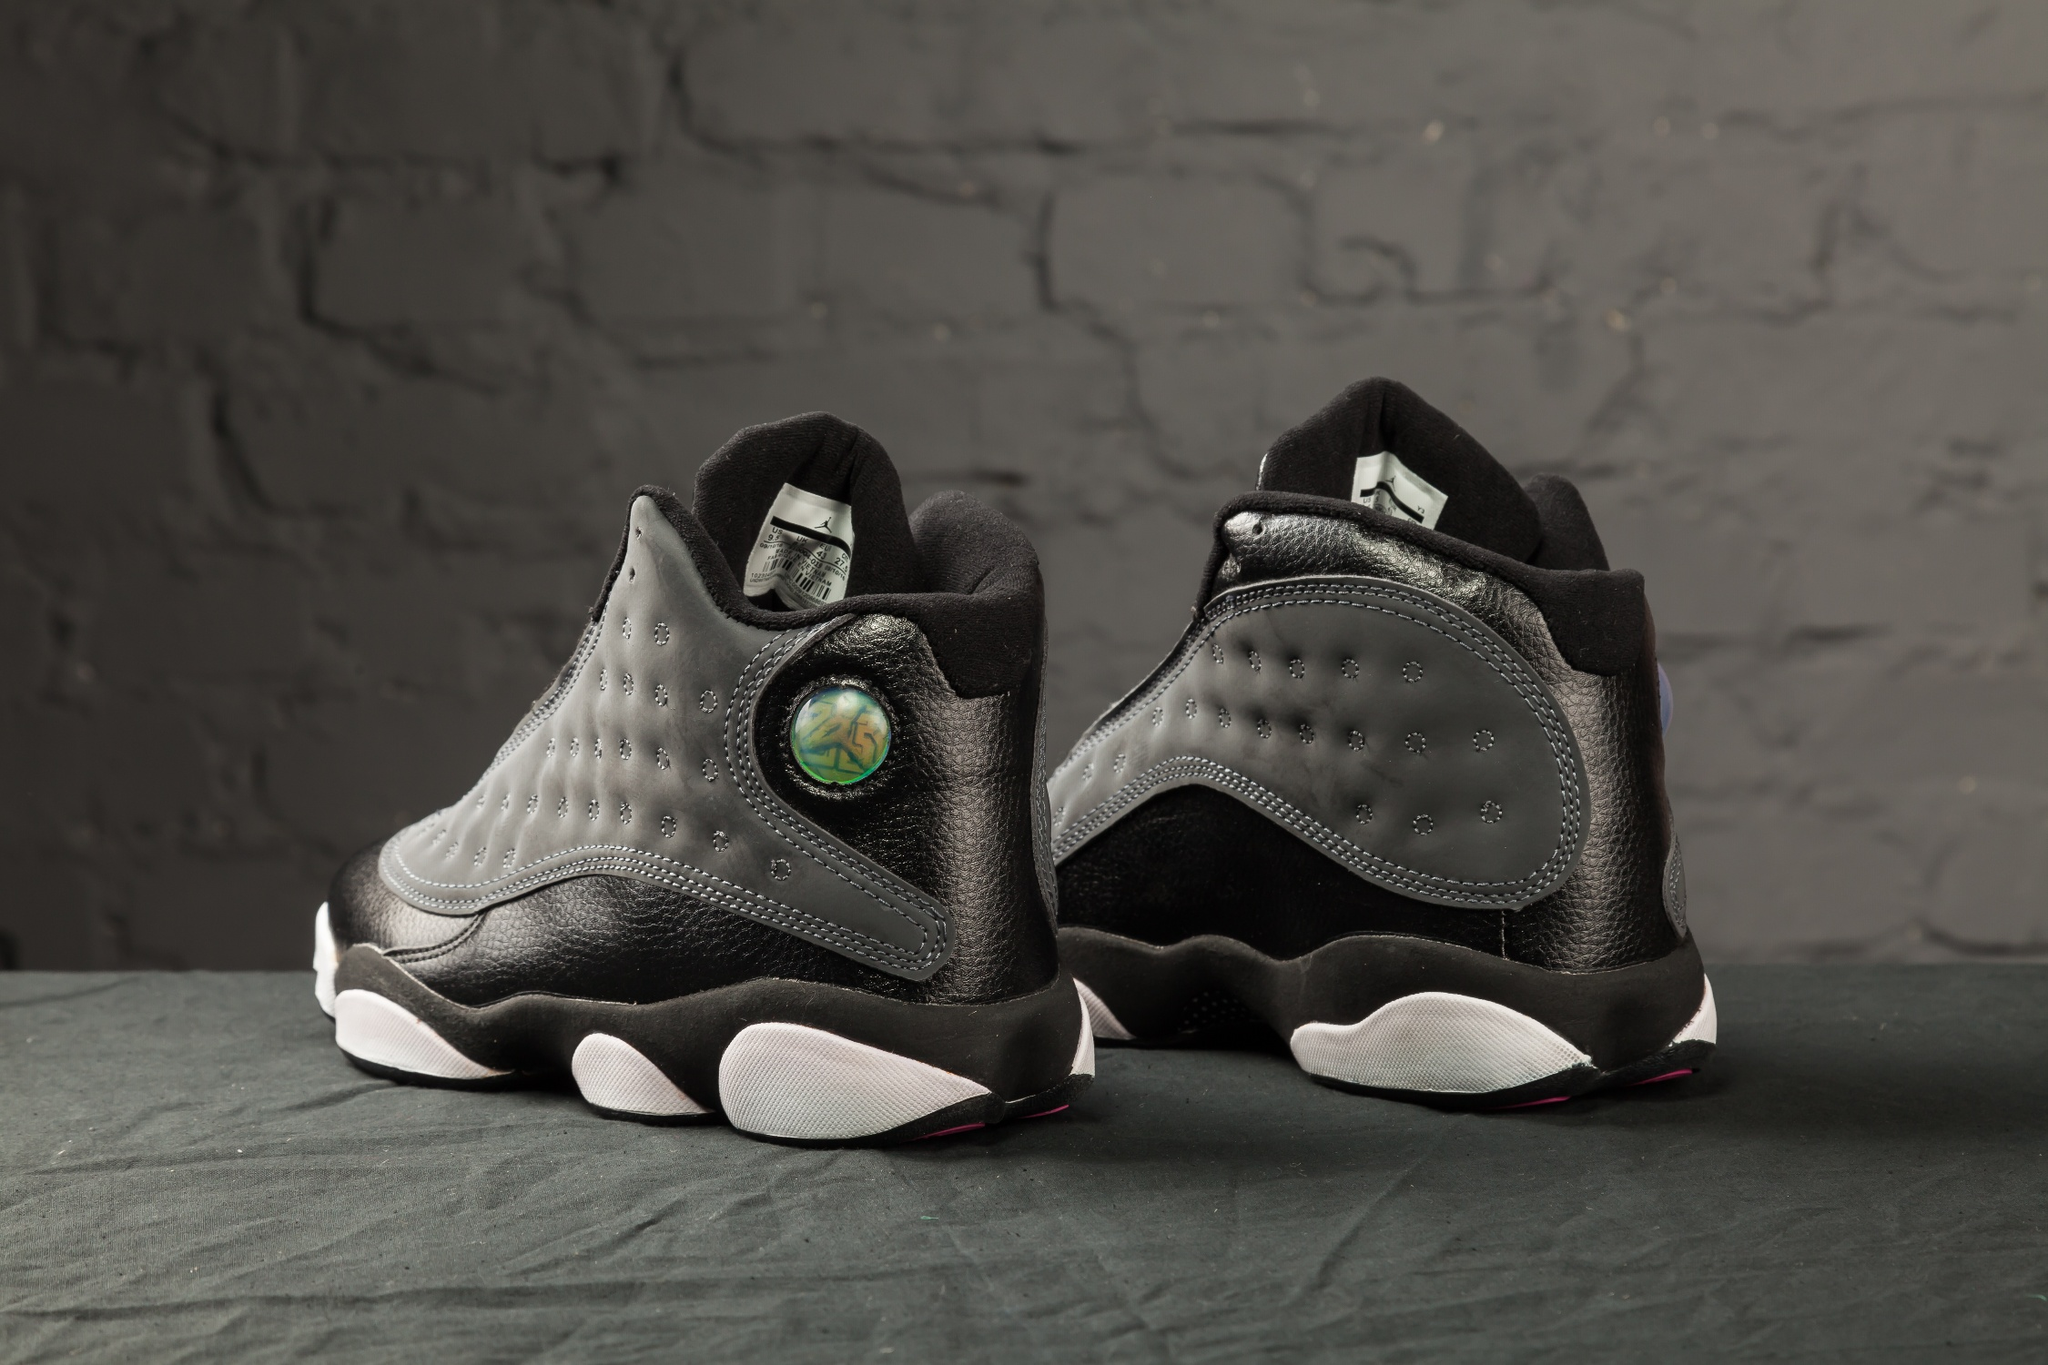What kind of materials and technology might have been used to make these sneakers? The sneakers likely boast a combination of premium materials and advanced technology. The upper part appears to be constructed from a mix of high-quality leather and synthetic overlays for durability and a sleek aesthetic. The soles are probably crafted from lightweight, responsive rubber, incorporating a cushioning technology aimed at providing optimal comfort and shock absorption. The holographic logo could be a finely crafted piece, possibly using lenticular technology to create the shifting appearance. Additionally, the sneakers might feature breathable mesh lining to enhance comfort and reduce moisture accumulation, making them perfect for long-wear scenarios. Given the urban aesthetic, what type of marketing campaign could promote these sneakers? The marketing campaign for these sneakers should capture the essence of urban lifestyle and futuristic flair. Visuals of the shoes against city backdrops, coupled with dynamic night scenes lit by neon signs and bustling streets, would appeal to the target audience. Street performances, graffiti art contests, and pop-up stores in key urban locations could be part of the campaign, engaging potential customers directly. Additionally, leveraging social media influencers in the fashion and tech spheres to showcase practical yet stylish uses of the sneakers would amplify their appeal. Campaign slogans like 'Step into the Future' and 'Urban Legends in the Making' can encapsulate the essence of these sneakers. What creative ideas can you think of for a photoshoot featuring these sneakers? For a photoshoot, imagine a futuristic urban setting with towering skyscrapers and neon lights. The sneakers would be showcased on models clad in stylish, avant-garde outfits, navigating through the cityscape. Scenes could include a model stepping out of a sleek, autonomous vehicle, another riding an electric skateboard, and a group of friends hanging out at a rooftop garden with a city view. To emphasize the holographic logo, shots could involve reflective surfaces and dynamic lighting that highlight its iridescence. Close-ups of the sneakers against graffiti walls, or amidst a blend of natural elements like greenery breaking through the urban concrete, can also create a compelling visual story. 